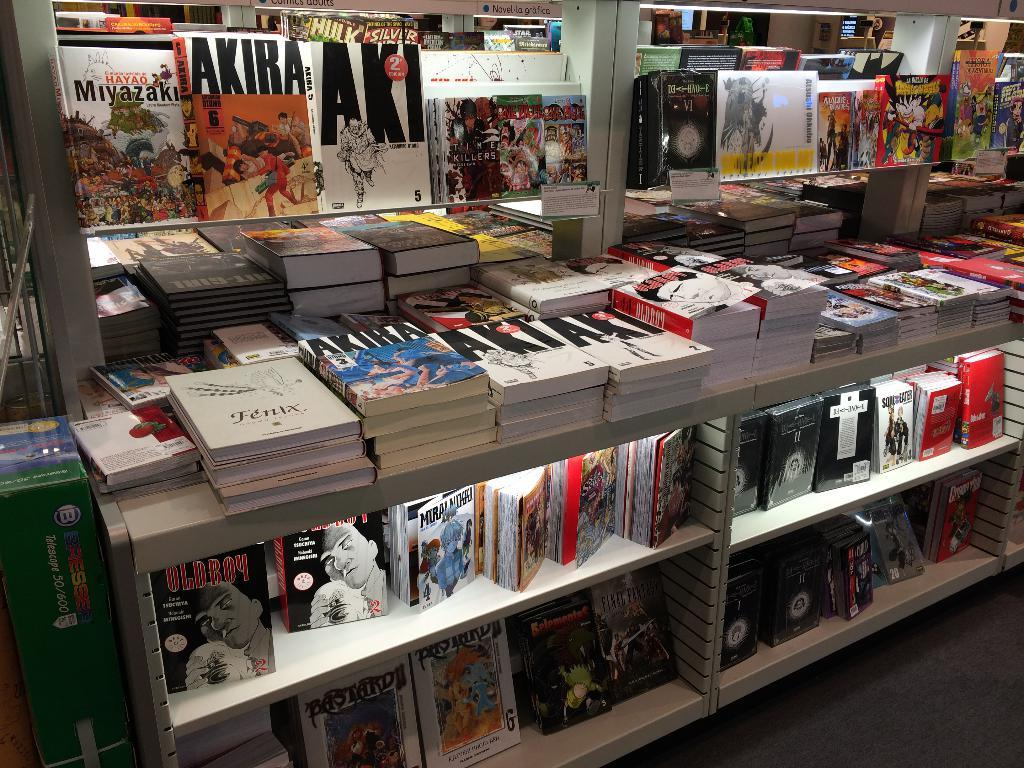<image>
Offer a succinct explanation of the picture presented. A display of a bunch of books with one titles AKIRA. 